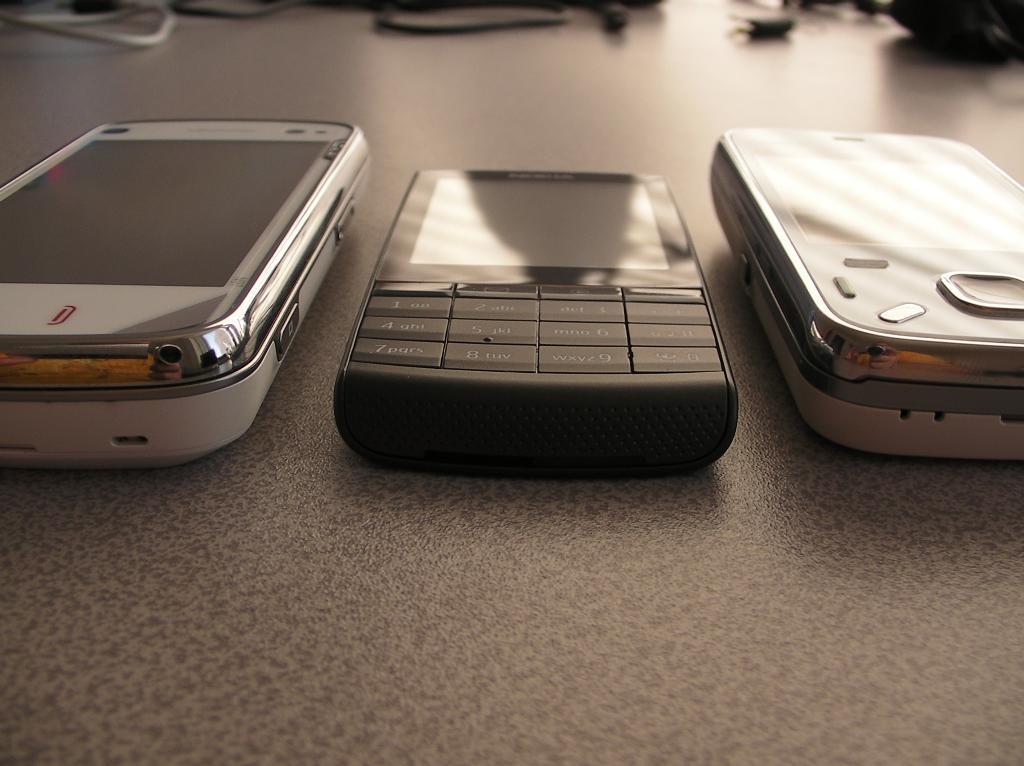Please provide a concise description of this image. In this image in the center there are three mobile phones, and at the bottom there is a table and in the background there are some wires and some objects. 